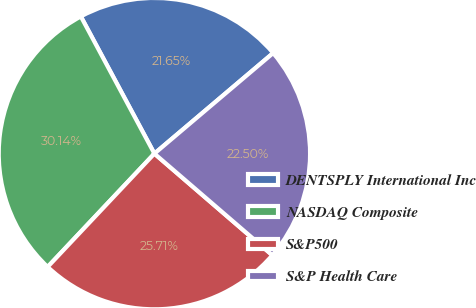<chart> <loc_0><loc_0><loc_500><loc_500><pie_chart><fcel>DENTSPLY International Inc<fcel>NASDAQ Composite<fcel>S&P500<fcel>S&P Health Care<nl><fcel>21.65%<fcel>30.14%<fcel>25.71%<fcel>22.5%<nl></chart> 